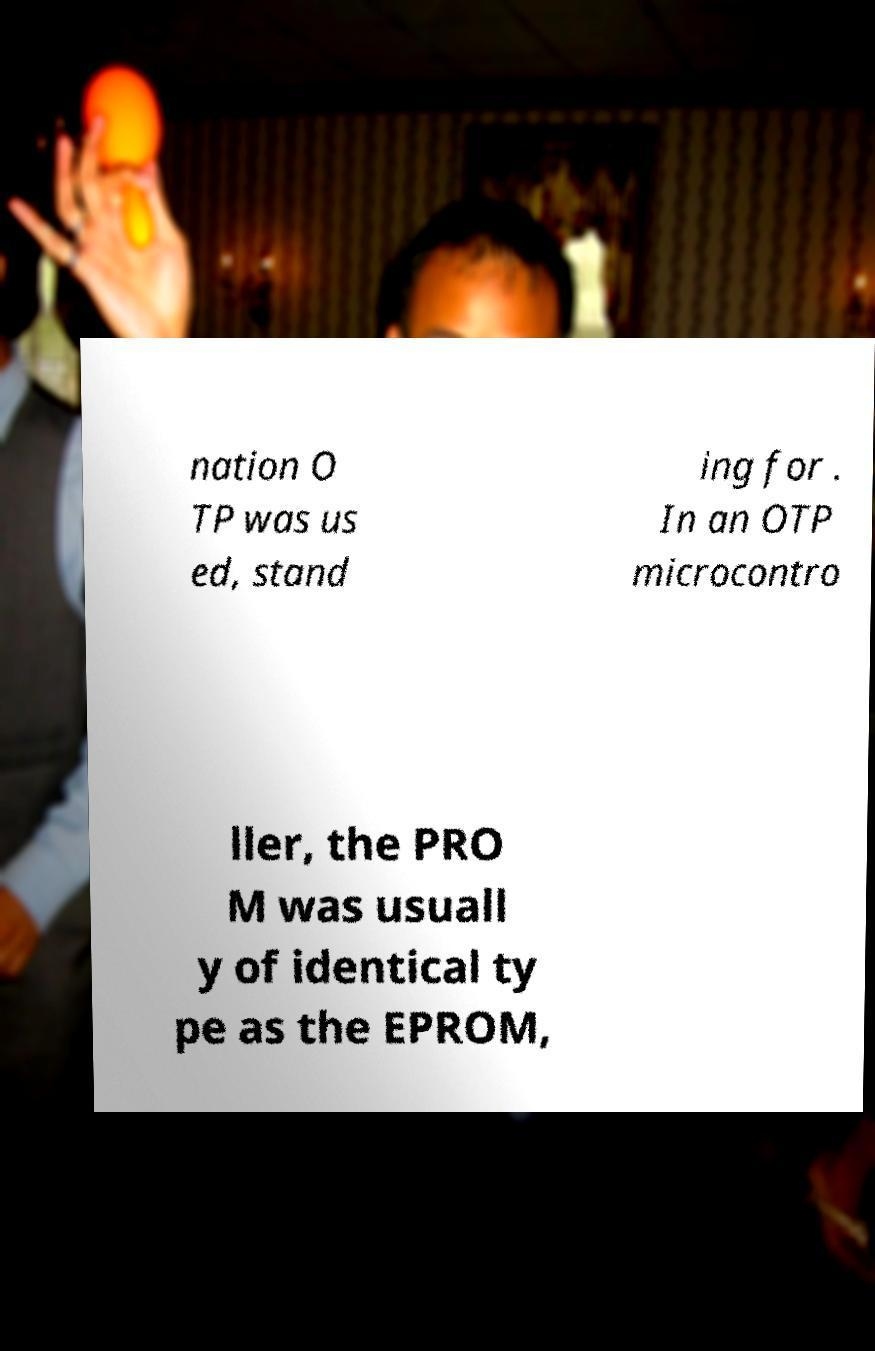For documentation purposes, I need the text within this image transcribed. Could you provide that? nation O TP was us ed, stand ing for . In an OTP microcontro ller, the PRO M was usuall y of identical ty pe as the EPROM, 